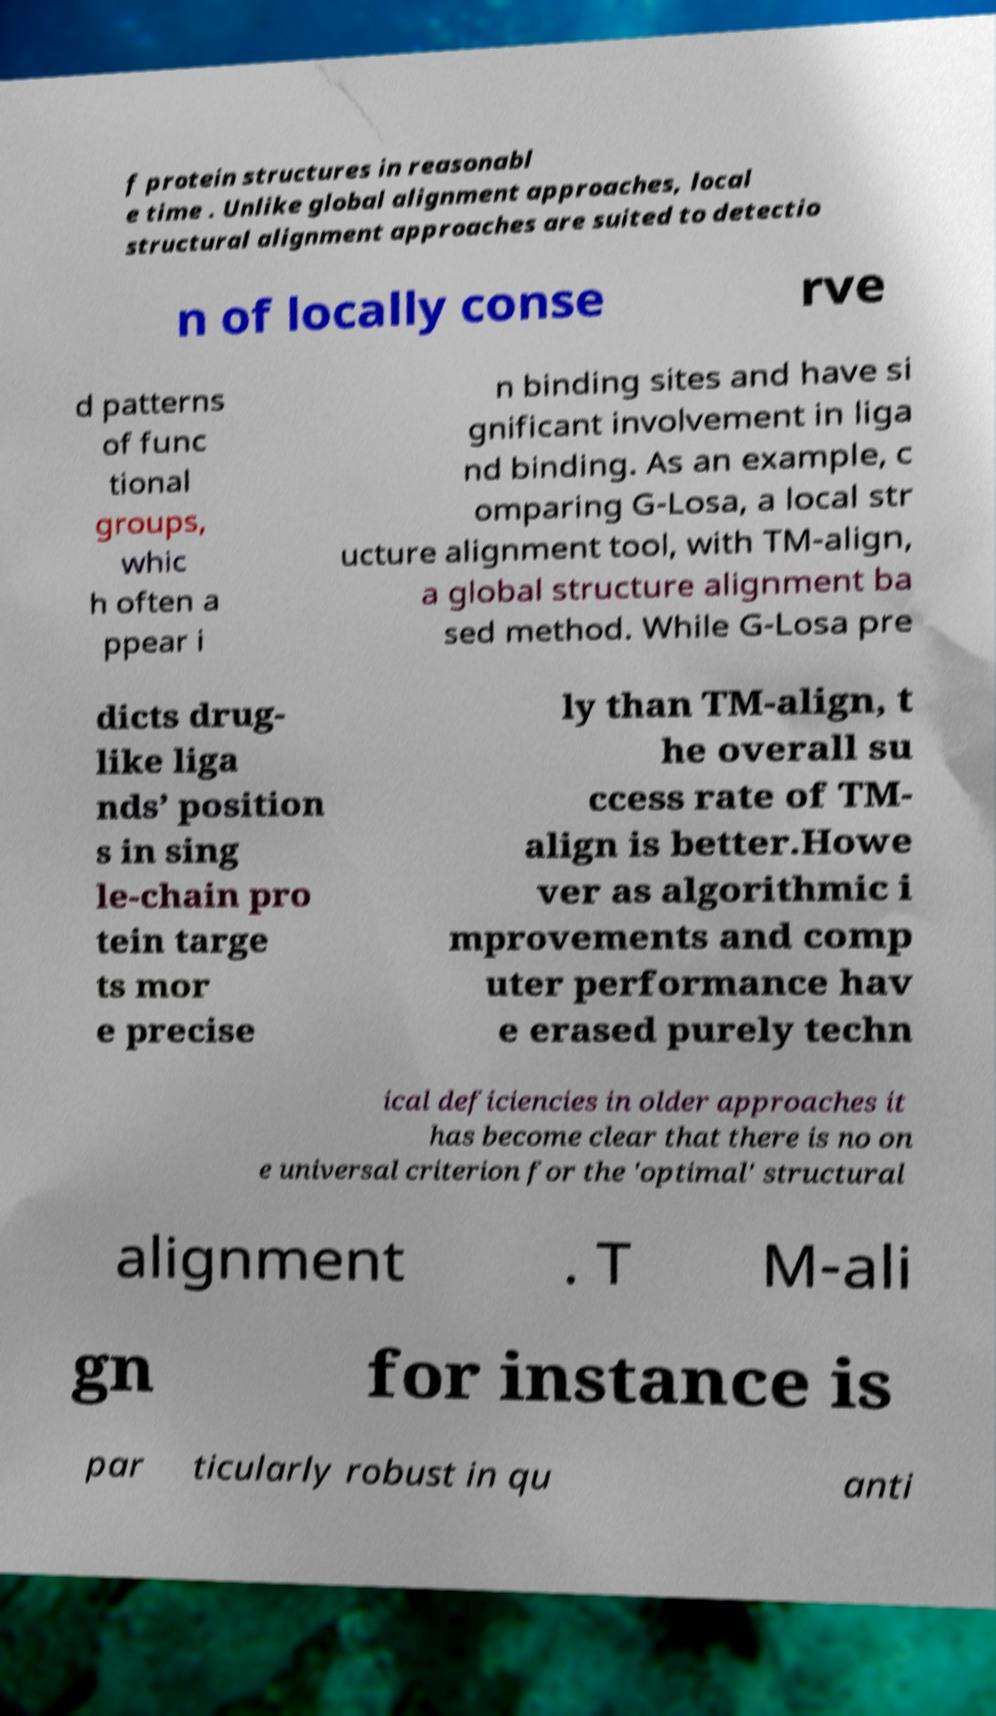Could you assist in decoding the text presented in this image and type it out clearly? f protein structures in reasonabl e time . Unlike global alignment approaches, local structural alignment approaches are suited to detectio n of locally conse rve d patterns of func tional groups, whic h often a ppear i n binding sites and have si gnificant involvement in liga nd binding. As an example, c omparing G-Losa, a local str ucture alignment tool, with TM-align, a global structure alignment ba sed method. While G-Losa pre dicts drug- like liga nds’ position s in sing le-chain pro tein targe ts mor e precise ly than TM-align, t he overall su ccess rate of TM- align is better.Howe ver as algorithmic i mprovements and comp uter performance hav e erased purely techn ical deficiencies in older approaches it has become clear that there is no on e universal criterion for the 'optimal' structural alignment . T M-ali gn for instance is par ticularly robust in qu anti 